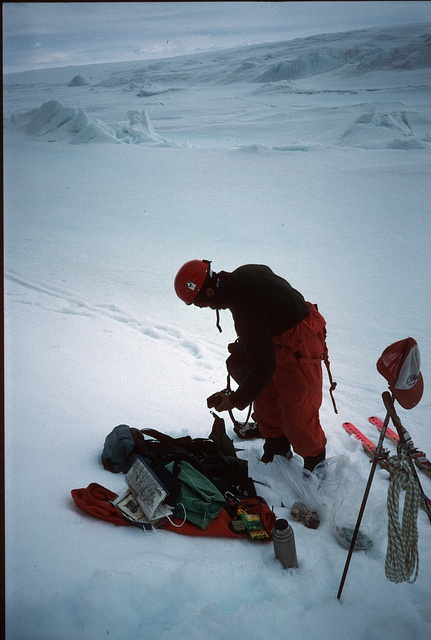Describe the objects in this image and their specific colors. I can see people in black, maroon, gray, and lightgray tones, backpack in black and teal tones, and skis in black, brown, and gray tones in this image. 